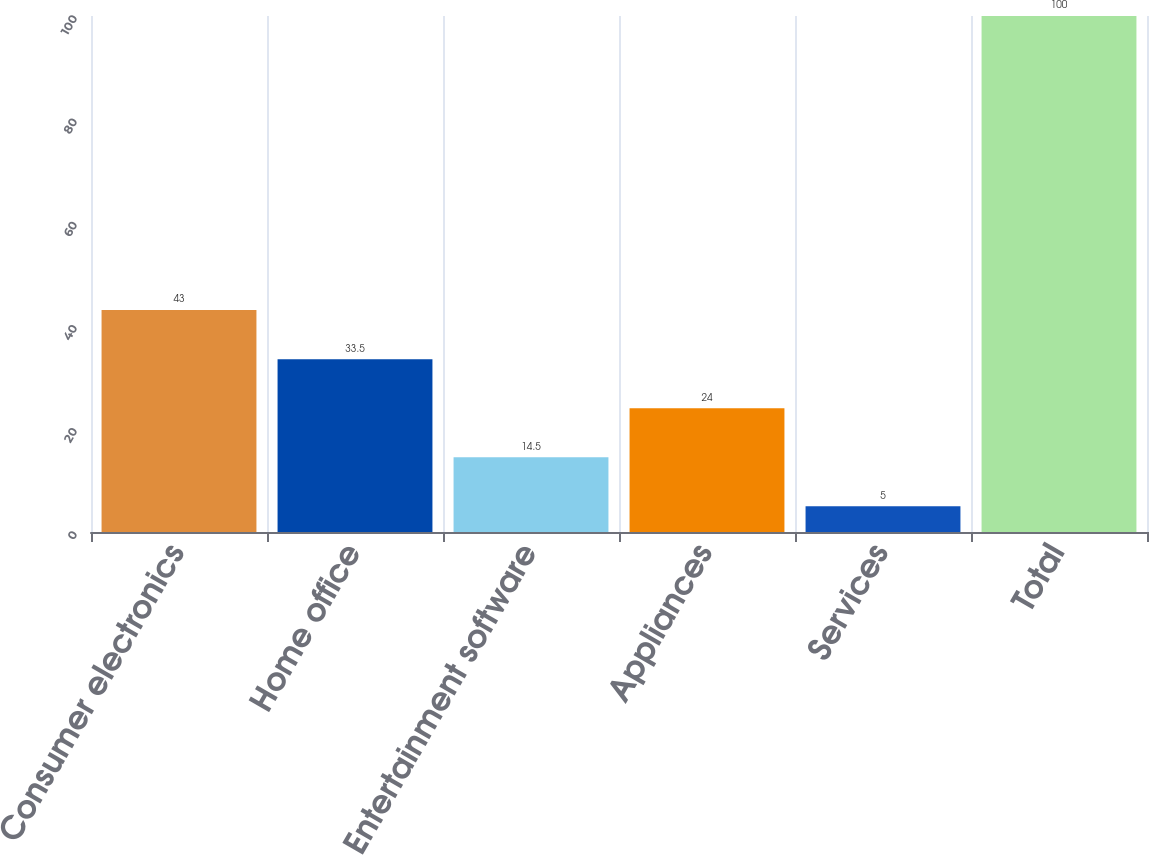Convert chart to OTSL. <chart><loc_0><loc_0><loc_500><loc_500><bar_chart><fcel>Consumer electronics<fcel>Home office<fcel>Entertainment software<fcel>Appliances<fcel>Services<fcel>Total<nl><fcel>43<fcel>33.5<fcel>14.5<fcel>24<fcel>5<fcel>100<nl></chart> 